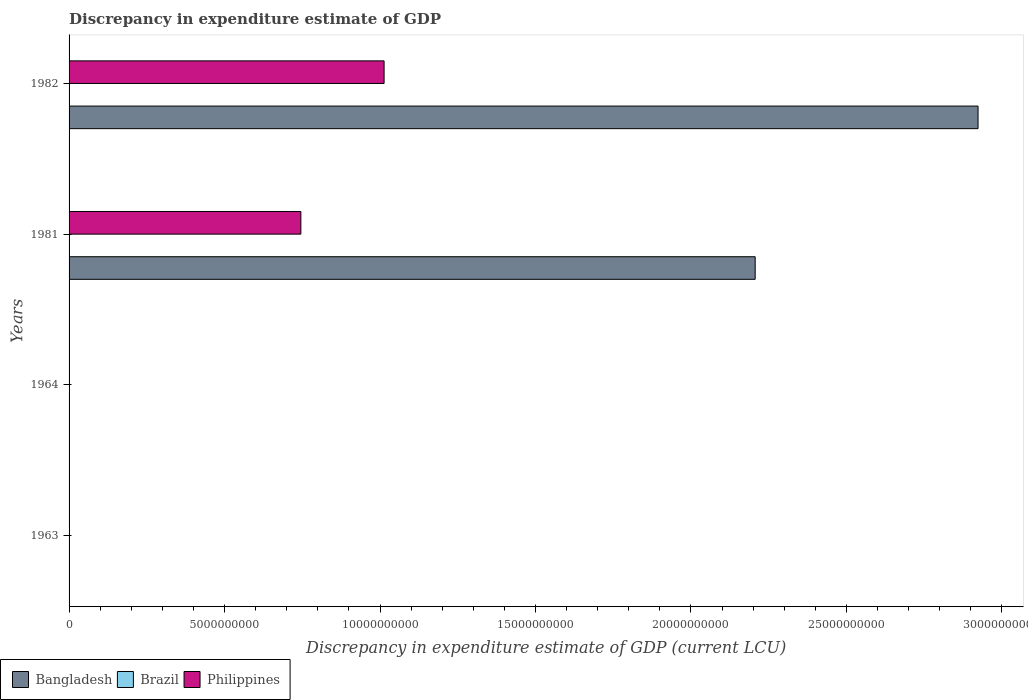How many different coloured bars are there?
Provide a succinct answer. 3. In how many cases, is the number of bars for a given year not equal to the number of legend labels?
Give a very brief answer. 4. What is the discrepancy in expenditure estimate of GDP in Brazil in 1982?
Ensure brevity in your answer.  0. Across all years, what is the maximum discrepancy in expenditure estimate of GDP in Bangladesh?
Your answer should be compact. 2.92e+1. Across all years, what is the minimum discrepancy in expenditure estimate of GDP in Bangladesh?
Provide a short and direct response. 0. In which year was the discrepancy in expenditure estimate of GDP in Philippines maximum?
Ensure brevity in your answer.  1982. What is the total discrepancy in expenditure estimate of GDP in Brazil in the graph?
Make the answer very short. 3e-10. What is the difference between the discrepancy in expenditure estimate of GDP in Philippines in 1981 and the discrepancy in expenditure estimate of GDP in Brazil in 1982?
Your answer should be very brief. 7.45e+09. What is the average discrepancy in expenditure estimate of GDP in Brazil per year?
Keep it short and to the point. 7.5e-11. In the year 1981, what is the difference between the discrepancy in expenditure estimate of GDP in Philippines and discrepancy in expenditure estimate of GDP in Bangladesh?
Give a very brief answer. -1.46e+1. What is the difference between the highest and the lowest discrepancy in expenditure estimate of GDP in Bangladesh?
Keep it short and to the point. 2.92e+1. Is the sum of the discrepancy in expenditure estimate of GDP in Bangladesh in 1981 and 1982 greater than the maximum discrepancy in expenditure estimate of GDP in Philippines across all years?
Offer a very short reply. Yes. Is it the case that in every year, the sum of the discrepancy in expenditure estimate of GDP in Bangladesh and discrepancy in expenditure estimate of GDP in Philippines is greater than the discrepancy in expenditure estimate of GDP in Brazil?
Offer a very short reply. No. How many bars are there?
Provide a succinct answer. 5. What is the difference between two consecutive major ticks on the X-axis?
Your answer should be very brief. 5.00e+09. Does the graph contain any zero values?
Your answer should be very brief. Yes. Does the graph contain grids?
Make the answer very short. No. Where does the legend appear in the graph?
Your answer should be very brief. Bottom left. How many legend labels are there?
Provide a short and direct response. 3. What is the title of the graph?
Provide a succinct answer. Discrepancy in expenditure estimate of GDP. Does "Ecuador" appear as one of the legend labels in the graph?
Provide a succinct answer. No. What is the label or title of the X-axis?
Offer a terse response. Discrepancy in expenditure estimate of GDP (current LCU). What is the label or title of the Y-axis?
Make the answer very short. Years. What is the Discrepancy in expenditure estimate of GDP (current LCU) in Brazil in 1963?
Offer a terse response. 3e-10. What is the Discrepancy in expenditure estimate of GDP (current LCU) of Brazil in 1964?
Ensure brevity in your answer.  0. What is the Discrepancy in expenditure estimate of GDP (current LCU) in Bangladesh in 1981?
Ensure brevity in your answer.  2.21e+1. What is the Discrepancy in expenditure estimate of GDP (current LCU) of Brazil in 1981?
Provide a succinct answer. 0. What is the Discrepancy in expenditure estimate of GDP (current LCU) in Philippines in 1981?
Offer a very short reply. 7.45e+09. What is the Discrepancy in expenditure estimate of GDP (current LCU) in Bangladesh in 1982?
Your answer should be very brief. 2.92e+1. What is the Discrepancy in expenditure estimate of GDP (current LCU) of Brazil in 1982?
Provide a succinct answer. 0. What is the Discrepancy in expenditure estimate of GDP (current LCU) of Philippines in 1982?
Your answer should be very brief. 1.01e+1. Across all years, what is the maximum Discrepancy in expenditure estimate of GDP (current LCU) in Bangladesh?
Give a very brief answer. 2.92e+1. Across all years, what is the maximum Discrepancy in expenditure estimate of GDP (current LCU) in Brazil?
Your answer should be compact. 3e-10. Across all years, what is the maximum Discrepancy in expenditure estimate of GDP (current LCU) of Philippines?
Your answer should be very brief. 1.01e+1. Across all years, what is the minimum Discrepancy in expenditure estimate of GDP (current LCU) in Philippines?
Offer a very short reply. 0. What is the total Discrepancy in expenditure estimate of GDP (current LCU) of Bangladesh in the graph?
Your answer should be very brief. 5.13e+1. What is the total Discrepancy in expenditure estimate of GDP (current LCU) of Brazil in the graph?
Make the answer very short. 0. What is the total Discrepancy in expenditure estimate of GDP (current LCU) in Philippines in the graph?
Offer a very short reply. 1.76e+1. What is the difference between the Discrepancy in expenditure estimate of GDP (current LCU) of Bangladesh in 1981 and that in 1982?
Your response must be concise. -7.17e+09. What is the difference between the Discrepancy in expenditure estimate of GDP (current LCU) of Philippines in 1981 and that in 1982?
Provide a short and direct response. -2.68e+09. What is the difference between the Discrepancy in expenditure estimate of GDP (current LCU) in Brazil in 1963 and the Discrepancy in expenditure estimate of GDP (current LCU) in Philippines in 1981?
Offer a very short reply. -7.45e+09. What is the difference between the Discrepancy in expenditure estimate of GDP (current LCU) of Brazil in 1963 and the Discrepancy in expenditure estimate of GDP (current LCU) of Philippines in 1982?
Offer a very short reply. -1.01e+1. What is the difference between the Discrepancy in expenditure estimate of GDP (current LCU) of Bangladesh in 1981 and the Discrepancy in expenditure estimate of GDP (current LCU) of Philippines in 1982?
Ensure brevity in your answer.  1.19e+1. What is the average Discrepancy in expenditure estimate of GDP (current LCU) of Bangladesh per year?
Your response must be concise. 1.28e+1. What is the average Discrepancy in expenditure estimate of GDP (current LCU) in Philippines per year?
Your response must be concise. 4.40e+09. In the year 1981, what is the difference between the Discrepancy in expenditure estimate of GDP (current LCU) of Bangladesh and Discrepancy in expenditure estimate of GDP (current LCU) of Philippines?
Offer a very short reply. 1.46e+1. In the year 1982, what is the difference between the Discrepancy in expenditure estimate of GDP (current LCU) in Bangladesh and Discrepancy in expenditure estimate of GDP (current LCU) in Philippines?
Your answer should be very brief. 1.91e+1. What is the ratio of the Discrepancy in expenditure estimate of GDP (current LCU) in Bangladesh in 1981 to that in 1982?
Provide a succinct answer. 0.75. What is the ratio of the Discrepancy in expenditure estimate of GDP (current LCU) in Philippines in 1981 to that in 1982?
Your answer should be very brief. 0.74. What is the difference between the highest and the lowest Discrepancy in expenditure estimate of GDP (current LCU) in Bangladesh?
Keep it short and to the point. 2.92e+1. What is the difference between the highest and the lowest Discrepancy in expenditure estimate of GDP (current LCU) in Brazil?
Provide a short and direct response. 0. What is the difference between the highest and the lowest Discrepancy in expenditure estimate of GDP (current LCU) of Philippines?
Offer a terse response. 1.01e+1. 